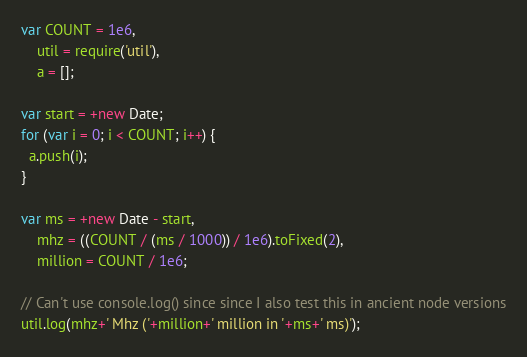Convert code to text. <code><loc_0><loc_0><loc_500><loc_500><_JavaScript_>var COUNT = 1e6,
    util = require('util'),
    a = [];

var start = +new Date;
for (var i = 0; i < COUNT; i++) {
  a.push(i);
}

var ms = +new Date - start,
    mhz = ((COUNT / (ms / 1000)) / 1e6).toFixed(2),
    million = COUNT / 1e6;

// Can't use console.log() since since I also test this in ancient node versions
util.log(mhz+' Mhz ('+million+' million in '+ms+' ms)');
</code> 